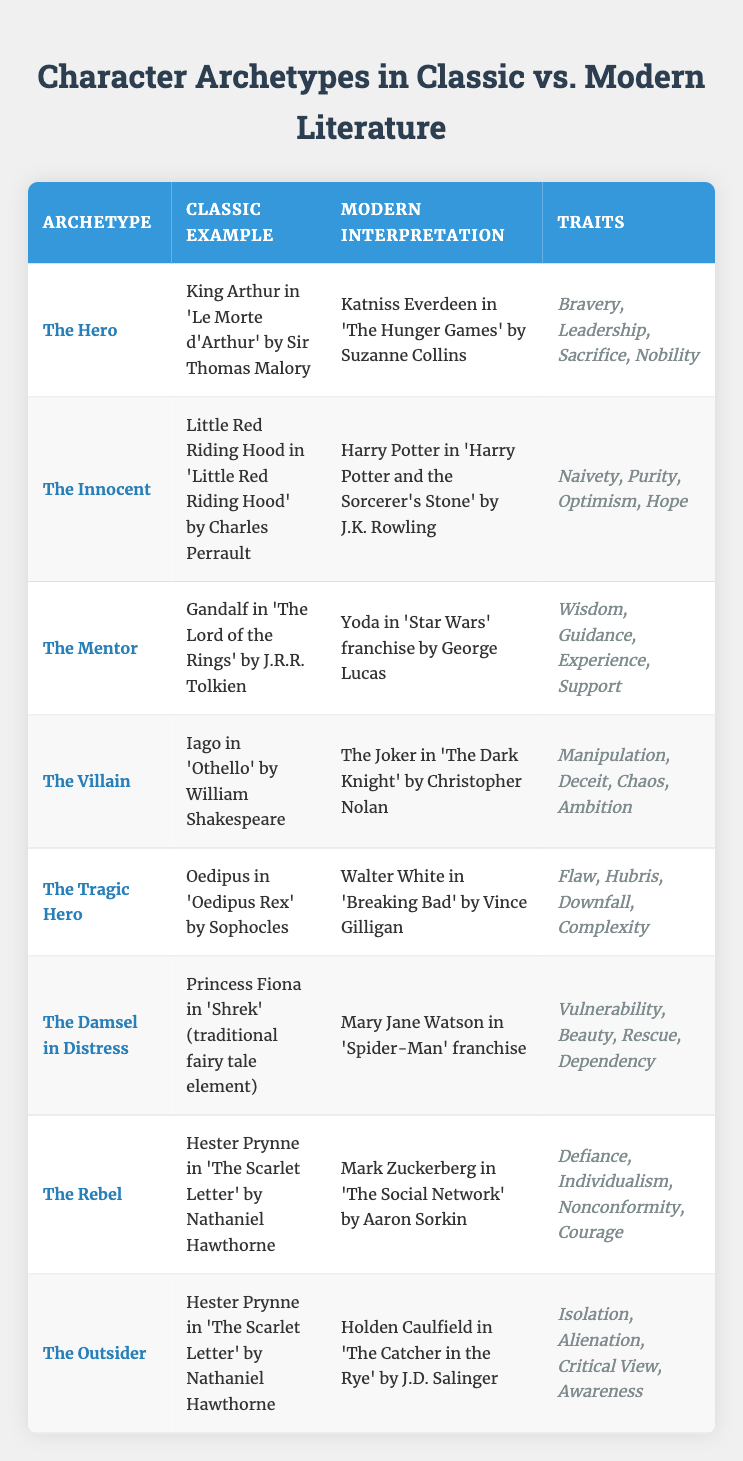What classic example corresponds to the archetype "The Mentor"? The table shows that Gandalf from "The Lord of the Rings" by J.R.R. Tolkien is the classic example for the archetype "The Mentor".
Answer: Gandalf in 'The Lord of the Rings' Which character is a modern interpretation of "The Damsel in Distress"? According to the table, Mary Jane Watson in the "Spider-Man" franchise is listed as the modern interpretation of the "The Damsel in Distress" archetype.
Answer: Mary Jane Watson in 'Spider-Man' True or false: Oedipus is classified as "The Hero" in the table. The table categorizes Oedipus as "The Tragic Hero", not "The Hero", making the statement false.
Answer: False What traits are common to both "The Villain" and "The Tragic Hero"? The traits for "The Villain" are Manipulation, Deceit, Chaos, Ambition; for "The Tragic Hero" they are Flaw, Hubris, Downfall, Complexity. There are no overlapping traits in the two archetypes.
Answer: None If we combine the traits of "The Rebel" and "The Outsider", what is the total number of unique traits? "The Rebel" has four traits: Defiance, Individualism, Nonconformity, Courage; "The Outsider" has four traits: Isolation, Alienation, Critical View, Awareness. Therefore, combining gives us eight unique traits in total.
Answer: 8 Which modern character represents "The Hero" and what trait do they share with the classic character? The modern character representing "The Hero" is Katniss Everdeen from "The Hunger Games". Both Katniss and King Arthur share the trait of "Bravery".
Answer: Bravery How many archetypes feature characters that identify as "rebels"? The table shows that Hester Prynne appears in two archetypes; "The Rebel" and "The Outsider", therefore there are two individual archetypes featuring characters that can be seen as rebels.
Answer: 2 Which character archetype showcases traits of Vulnerability and Beauty? The Damsel in Distress archetype features traits including Vulnerability and Beauty, as stated in the table.
Answer: The Damsel in Distress 